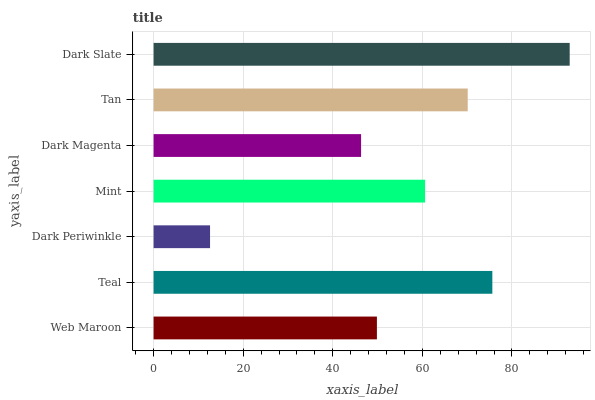Is Dark Periwinkle the minimum?
Answer yes or no. Yes. Is Dark Slate the maximum?
Answer yes or no. Yes. Is Teal the minimum?
Answer yes or no. No. Is Teal the maximum?
Answer yes or no. No. Is Teal greater than Web Maroon?
Answer yes or no. Yes. Is Web Maroon less than Teal?
Answer yes or no. Yes. Is Web Maroon greater than Teal?
Answer yes or no. No. Is Teal less than Web Maroon?
Answer yes or no. No. Is Mint the high median?
Answer yes or no. Yes. Is Mint the low median?
Answer yes or no. Yes. Is Dark Slate the high median?
Answer yes or no. No. Is Tan the low median?
Answer yes or no. No. 